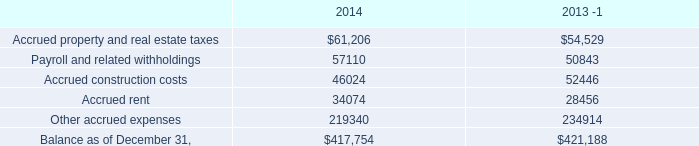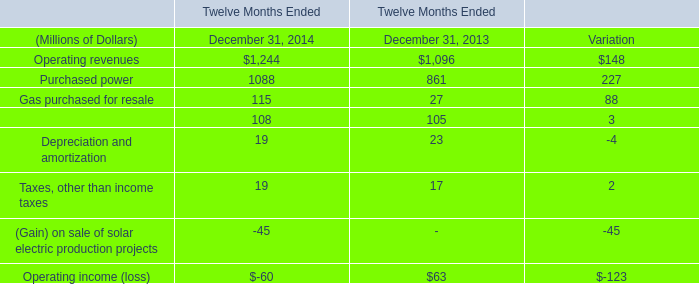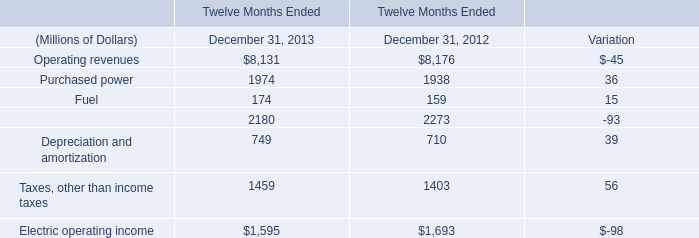how much of the of contingent consideration for acquisitions was actually settled in 2014? 
Computations: (0.4 / 6.3)
Answer: 0.06349. 